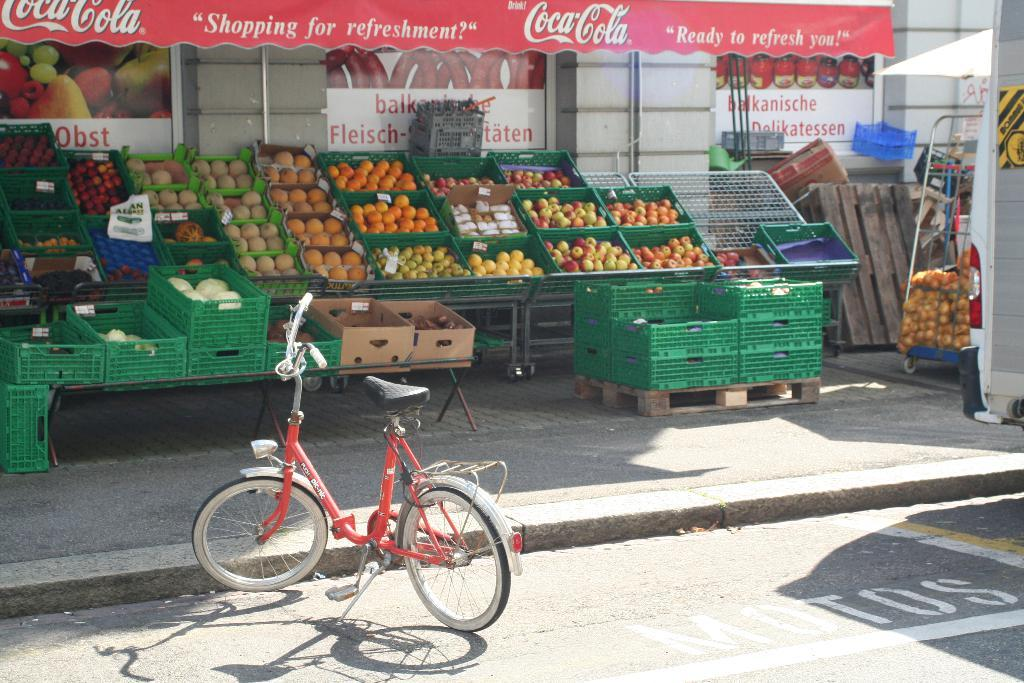<image>
Present a compact description of the photo's key features. An awning with Coca Cola on it hangs above cartons of fruit in an outdoor market. 